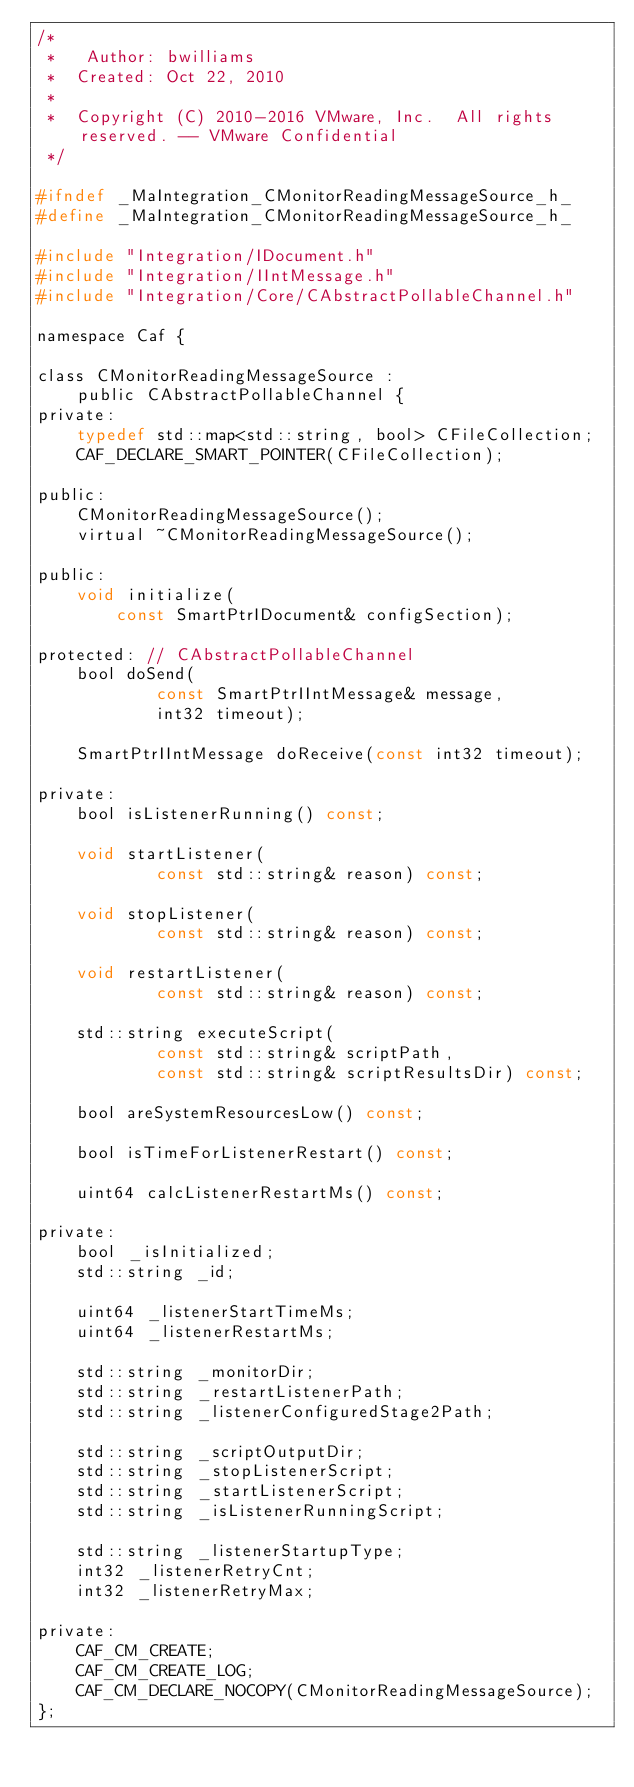Convert code to text. <code><loc_0><loc_0><loc_500><loc_500><_C_>/*
 *	 Author: bwilliams
 *  Created: Oct 22, 2010
 *
 *	Copyright (C) 2010-2016 VMware, Inc.  All rights reserved. -- VMware Confidential
 */

#ifndef _MaIntegration_CMonitorReadingMessageSource_h_
#define _MaIntegration_CMonitorReadingMessageSource_h_

#include "Integration/IDocument.h"
#include "Integration/IIntMessage.h"
#include "Integration/Core/CAbstractPollableChannel.h"

namespace Caf {

class CMonitorReadingMessageSource :
	public CAbstractPollableChannel {
private:
	typedef std::map<std::string, bool> CFileCollection;
	CAF_DECLARE_SMART_POINTER(CFileCollection);

public:
	CMonitorReadingMessageSource();
	virtual ~CMonitorReadingMessageSource();

public:
	void initialize(
		const SmartPtrIDocument& configSection);

protected: // CAbstractPollableChannel
	bool doSend(
			const SmartPtrIIntMessage& message,
			int32 timeout);

	SmartPtrIIntMessage doReceive(const int32 timeout);

private:
	bool isListenerRunning() const;

	void startListener(
			const std::string& reason) const;

	void stopListener(
			const std::string& reason) const;

	void restartListener(
			const std::string& reason) const;

	std::string executeScript(
			const std::string& scriptPath,
			const std::string& scriptResultsDir) const;

	bool areSystemResourcesLow() const;

	bool isTimeForListenerRestart() const;

	uint64 calcListenerRestartMs() const;

private:
	bool _isInitialized;
	std::string _id;

	uint64 _listenerStartTimeMs;
	uint64 _listenerRestartMs;

	std::string _monitorDir;
	std::string _restartListenerPath;
	std::string _listenerConfiguredStage2Path;

	std::string _scriptOutputDir;
	std::string _stopListenerScript;
	std::string _startListenerScript;
	std::string _isListenerRunningScript;

	std::string _listenerStartupType;
	int32 _listenerRetryCnt;
	int32 _listenerRetryMax;

private:
	CAF_CM_CREATE;
	CAF_CM_CREATE_LOG;
	CAF_CM_DECLARE_NOCOPY(CMonitorReadingMessageSource);
};
</code> 